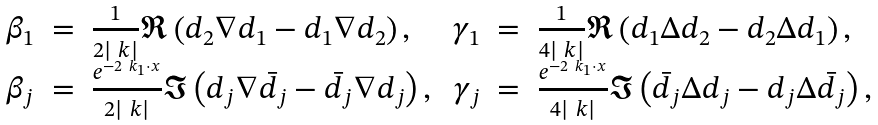<formula> <loc_0><loc_0><loc_500><loc_500>\begin{array} { r c l r c l } \beta _ { 1 } & = & \frac { 1 } { 2 | \ k | } \Re \left ( d _ { 2 } \nabla d _ { 1 } - d _ { 1 } \nabla d _ { 2 } \right ) , \, & \gamma _ { 1 } & = & \frac { 1 } { 4 | \ k | } \Re \left ( d _ { 1 } \Delta d _ { 2 } - d _ { 2 } \Delta d _ { 1 } \right ) , \\ \beta _ { j } & = & \frac { e ^ { - 2 \ k _ { 1 } \cdot x } } { 2 | \ k | } \Im \left ( d _ { j } \nabla \bar { d _ { j } } - \bar { d _ { j } } \nabla d _ { j } \right ) , \, & \gamma _ { j } & = & \frac { e ^ { - 2 \ k _ { 1 } \cdot x } } { 4 | \ k | } \Im \left ( \bar { d _ { j } } \Delta d _ { j } - d _ { j } \Delta { \bar { d } _ { j } } \right ) , \end{array}</formula> 